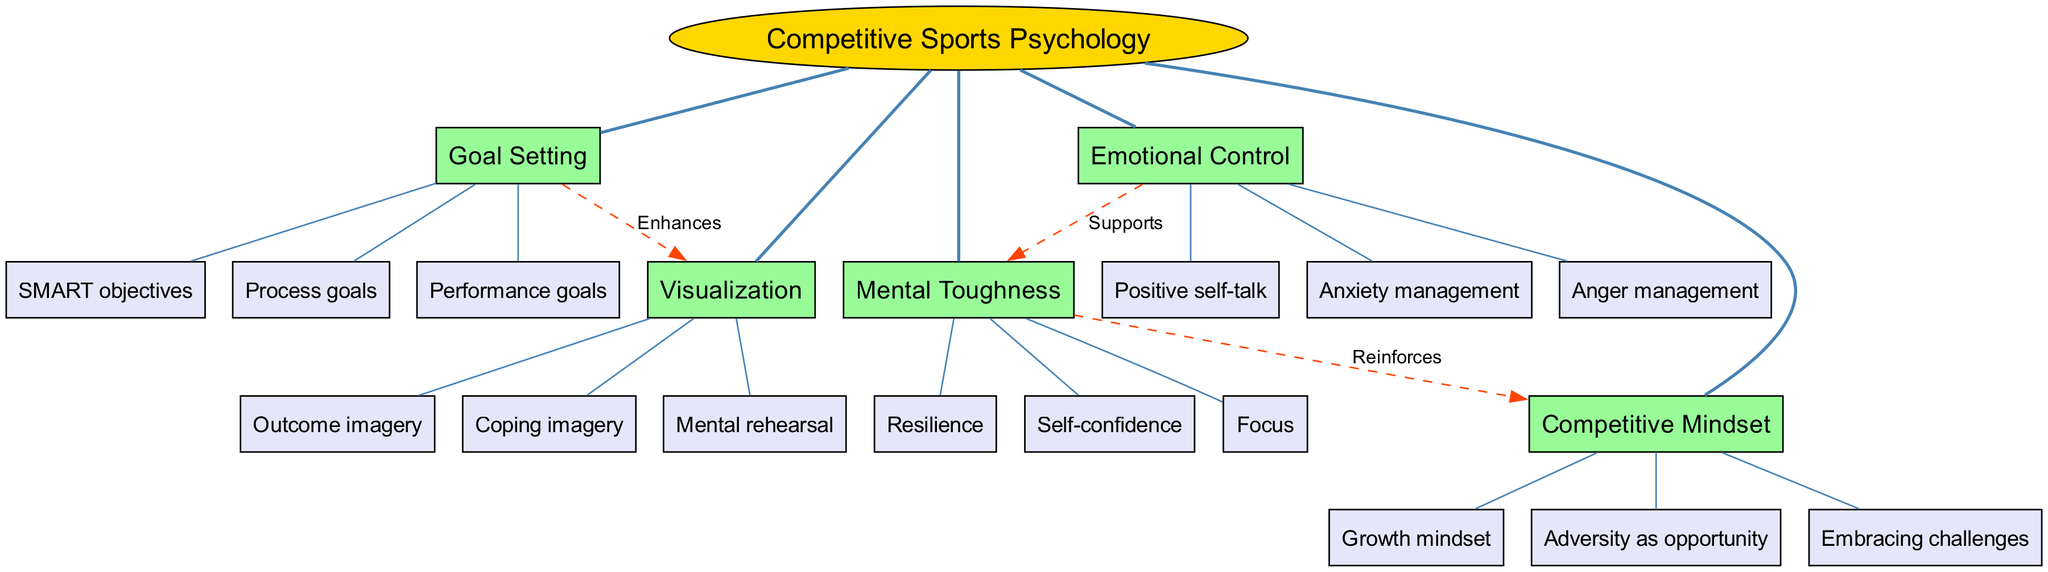What is the central concept of the diagram? The diagram clearly identifies "Competitive Sports Psychology" at the center, representing the main theme around which all branches and connections are structured.
Answer: Competitive Sports Psychology How many main branches are there in the diagram? By analyzing the structure of the diagram, I can count the five main branches listed: Mental Toughness, Goal Setting, Visualization, Emotional Control, and Competitive Mindset.
Answer: 5 Which branch supports Mental Toughness? The diagram shows a connection from the "Emotional Control" branch to "Mental Toughness," indicating that Emotional Control plays a supportive role in developing this mental quality.
Answer: Emotional Control How many sub-branches are under Goal Setting? The branch "Goal Setting" has three sub-branches: SMART objectives, Process goals, and Performance goals. Counting these gives a total of three sub-branches.
Answer: 3 What type of relationship exists between Mental Toughness and Competitive Mindset? The diagram indicates a "Reinforces" relationship, suggesting that Mental Toughness contributes positively to developing a Competitive Mindset.
Answer: Reinforces Which branch enhances Visualization? In the diagram, there is a connection labeled "Enhances" from the "Goal Setting" branch to "Visualization," highlighting that effective goal setting improves visualization techniques.
Answer: Goal Setting What is one sub-branch of Emotional Control? The sub-branches of Emotional Control include Anxiety management, Anger management, and Positive self-talk. Choosing any one of these is a valid answer.
Answer: Positive self-talk What does a growth mindset relate to in the context of competitive sports psychology? According to the diagram, a "Growth mindset" is a sub-branch of the "Competitive Mindset," indicating its importance in fostering a healthy competitive attitude among athletes.
Answer: Competitive Mindset Which main branch connects to Visualization through enhancement? The diagram reflects that the "Goal Setting" branch connects to "Visualization," showing that it enhances the process of mental imagery techniques used by athletes.
Answer: Goal Setting 